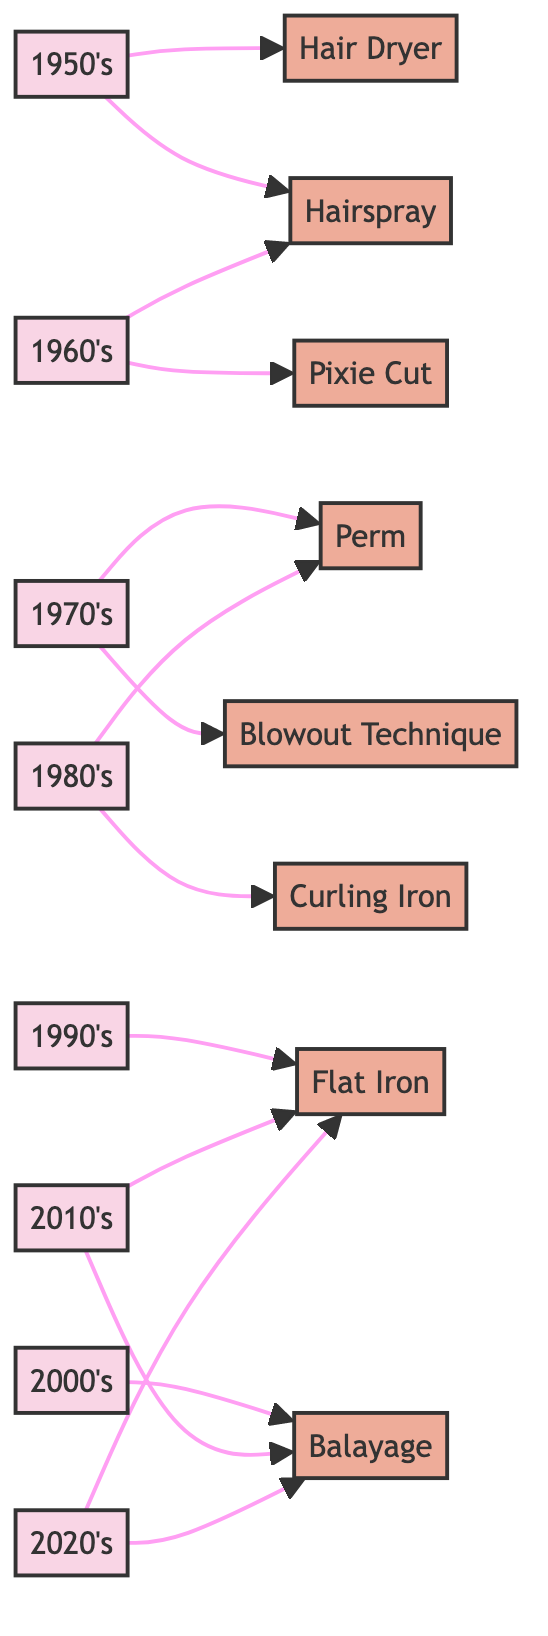What decade is associated with the Pixie Cut? The Pixie Cut is connected to the 1960s node in the diagram, indicating that this hairstyle became popular during that decade.
Answer: 1960s How many techniques are linked to the 1980s? By reviewing the edges connected to the 1980s node, we see two techniques: Curling Iron and Perm, which means there are two techniques linked to this decade.
Answer: 2 Which decade first introduced the Blowout Technique? The Blowout Technique is connected to the 1970s node, indicating that it was introduced during that decade.
Answer: 1970s What is the last decade mentioned in the diagram? Observing the nodes in the diagram reveals that the final decade listed is the 2020s.
Answer: 2020s What technique is commonly associated with the 2000s? The Balayage technique is specifically linked to the 2000s, suggesting it gained popularity during this time.
Answer: Balayage Which two techniques have connections to both the 2010s and 2020s? By examining the connections, we see that both Balayage and Flat Iron are linked to both the 2010s and 2020s nodes.
Answer: Balayage, Flat Iron How many decades are displayed in the diagram? Counting the node entries designated for decades, we find eight total decades represented in the diagram (from the 1950s to the 2020s).
Answer: 8 What is the relationship between the 1950s and Hairspray? The Hairspray node points directly from the 1950s node, indicating that Hairspray is associated with the 1950s decade.
Answer: Associated Which technique was prevalent in both the 1970s and 1980s? The Perm technique is connected to both the 1970s and 1980s nodes, demonstrating its popularity in those two decades.
Answer: Perm 